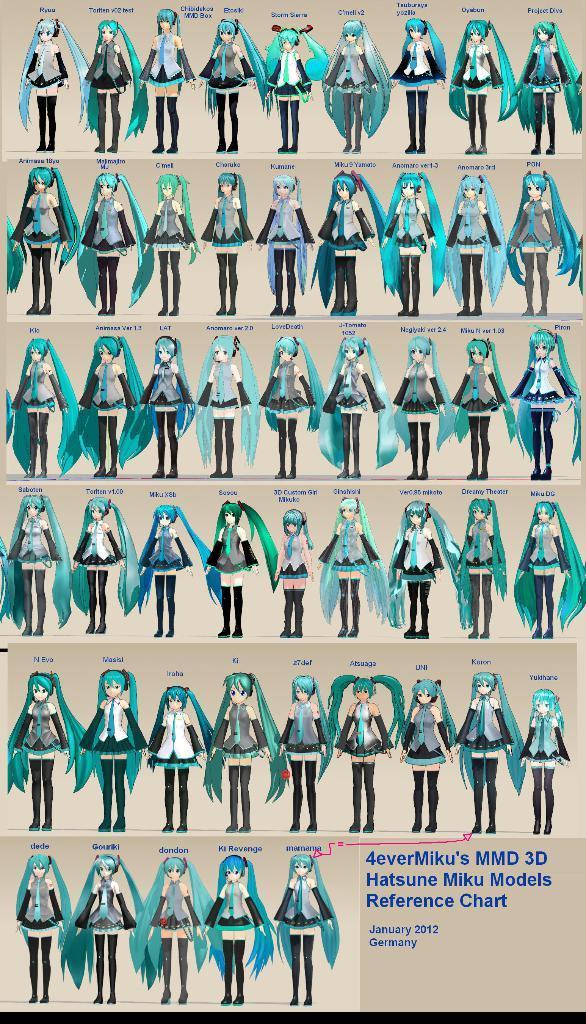How would you summarize this image in a sentence or two? In this picture there is a poster. On the poster there are group of people standing. At the bottom left there is text. 